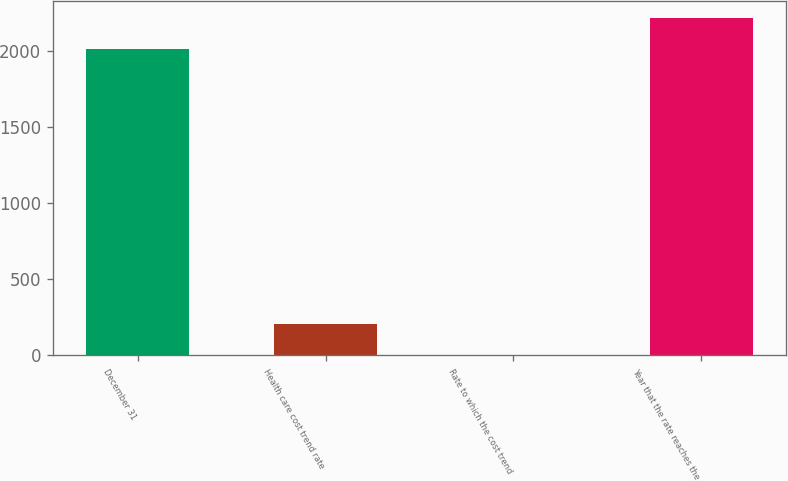<chart> <loc_0><loc_0><loc_500><loc_500><bar_chart><fcel>December 31<fcel>Health care cost trend rate<fcel>Rate to which the cost trend<fcel>Year that the rate reaches the<nl><fcel>2015<fcel>206.6<fcel>5<fcel>2216.6<nl></chart> 